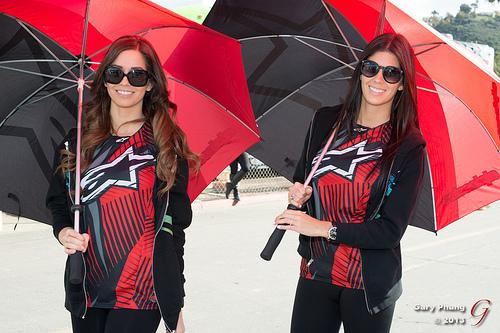Question: why do they look the same?
Choices:
A. They are twins.
B. They are actors.
C. They are in costumes.
D. They are models.
Answer with the letter. Answer: A Question: what are they holding?
Choices:
A. Cameras.
B. Backpacks.
C. Books.
D. Umbrellas.
Answer with the letter. Answer: D Question: what are on the shirts?
Choices:
A. Pockets.
B. Flowers.
C. Stripes.
D. Stars.
Answer with the letter. Answer: D Question: what year was this photo taken?
Choices:
A. 2000.
B. 1999.
C. 2012.
D. 2013.
Answer with the letter. Answer: D Question: what color are the umbrellas?
Choices:
A. Blue.
B. Red and black.
C. Black.
D. Tan.
Answer with the letter. Answer: B 